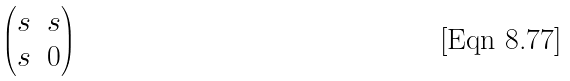<formula> <loc_0><loc_0><loc_500><loc_500>\begin{pmatrix} s & s \\ s & 0 \end{pmatrix}</formula> 